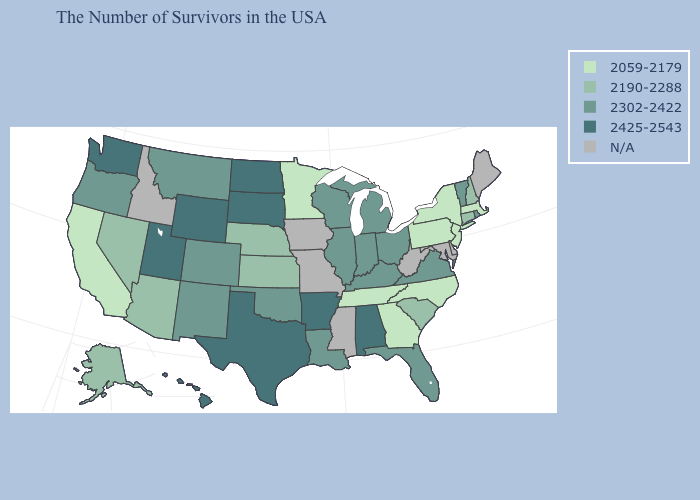Which states have the lowest value in the Northeast?
Concise answer only. Massachusetts, New York, New Jersey, Pennsylvania. What is the value of Nevada?
Write a very short answer. 2190-2288. Name the states that have a value in the range 2190-2288?
Short answer required. New Hampshire, Connecticut, South Carolina, Kansas, Nebraska, Arizona, Nevada, Alaska. What is the value of Michigan?
Give a very brief answer. 2302-2422. What is the value of Idaho?
Answer briefly. N/A. What is the value of Oklahoma?
Concise answer only. 2302-2422. What is the highest value in the MidWest ?
Answer briefly. 2425-2543. What is the value of New York?
Be succinct. 2059-2179. Name the states that have a value in the range 2059-2179?
Write a very short answer. Massachusetts, New York, New Jersey, Pennsylvania, North Carolina, Georgia, Tennessee, Minnesota, California. Name the states that have a value in the range 2302-2422?
Quick response, please. Rhode Island, Vermont, Virginia, Ohio, Florida, Michigan, Kentucky, Indiana, Wisconsin, Illinois, Louisiana, Oklahoma, Colorado, New Mexico, Montana, Oregon. What is the value of Minnesota?
Quick response, please. 2059-2179. Among the states that border New Mexico , which have the lowest value?
Be succinct. Arizona. 